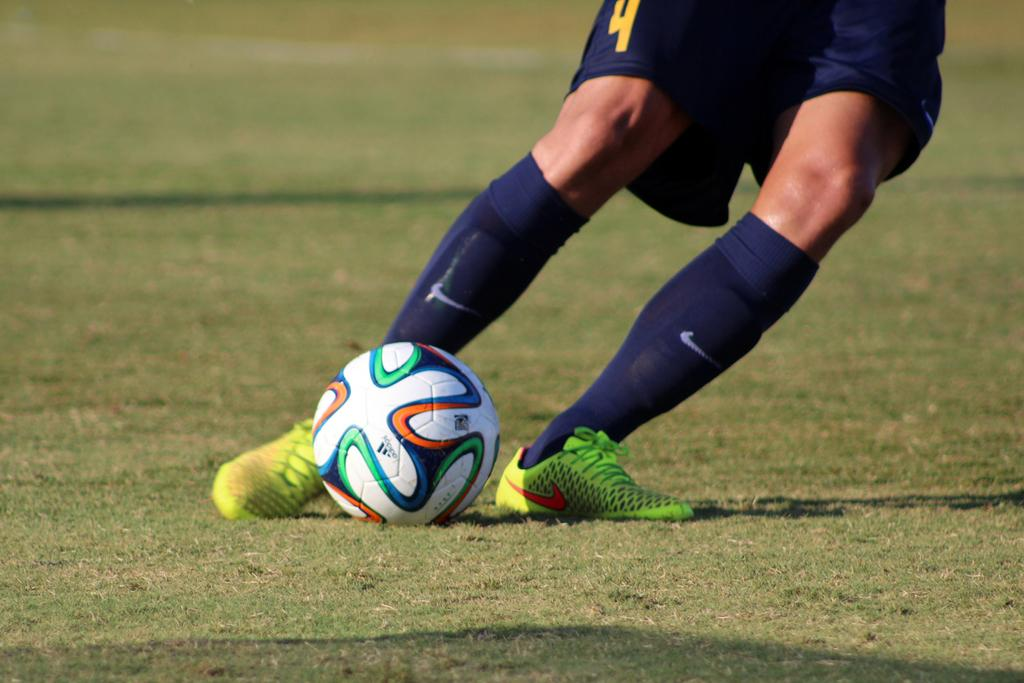<image>
Write a terse but informative summary of the picture. A person with the number 4 on their shorts kicks a soccer ball. 